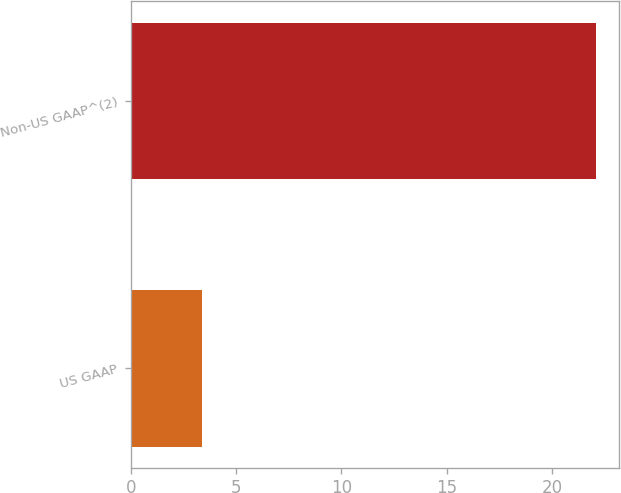<chart> <loc_0><loc_0><loc_500><loc_500><bar_chart><fcel>US GAAP<fcel>Non-US GAAP^(2)<nl><fcel>3.4<fcel>22.1<nl></chart> 